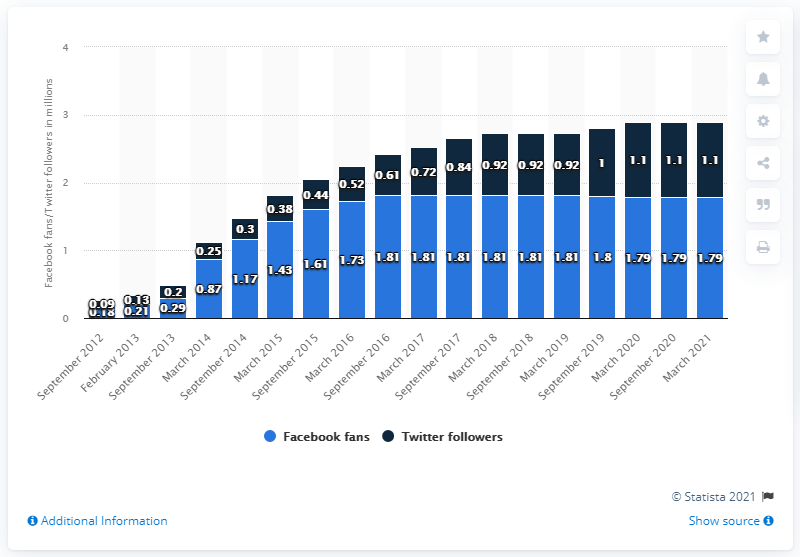Mention a couple of crucial points in this snapshot. In March 2021, the Memphis Grizzlies basketball team had 1.79 million fans on Facebook. 